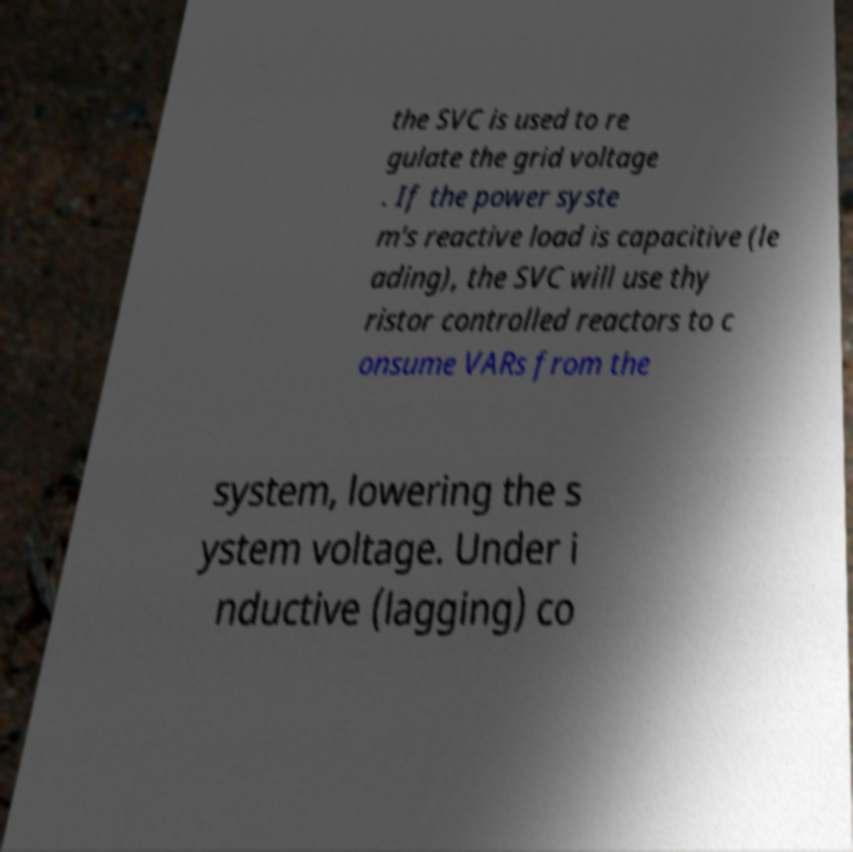Could you extract and type out the text from this image? the SVC is used to re gulate the grid voltage . If the power syste m's reactive load is capacitive (le ading), the SVC will use thy ristor controlled reactors to c onsume VARs from the system, lowering the s ystem voltage. Under i nductive (lagging) co 